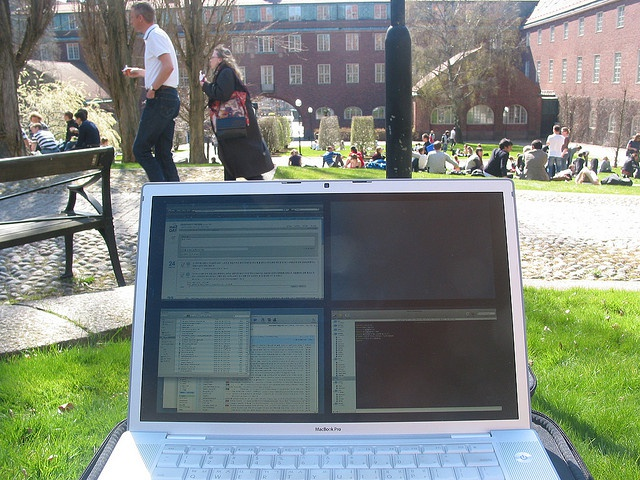Describe the objects in this image and their specific colors. I can see laptop in black, gray, lightblue, and navy tones, bench in black, gray, darkgray, and lightgray tones, people in black, lavender, and gray tones, people in black, gray, and darkgray tones, and people in black, white, gray, darkgray, and khaki tones in this image. 